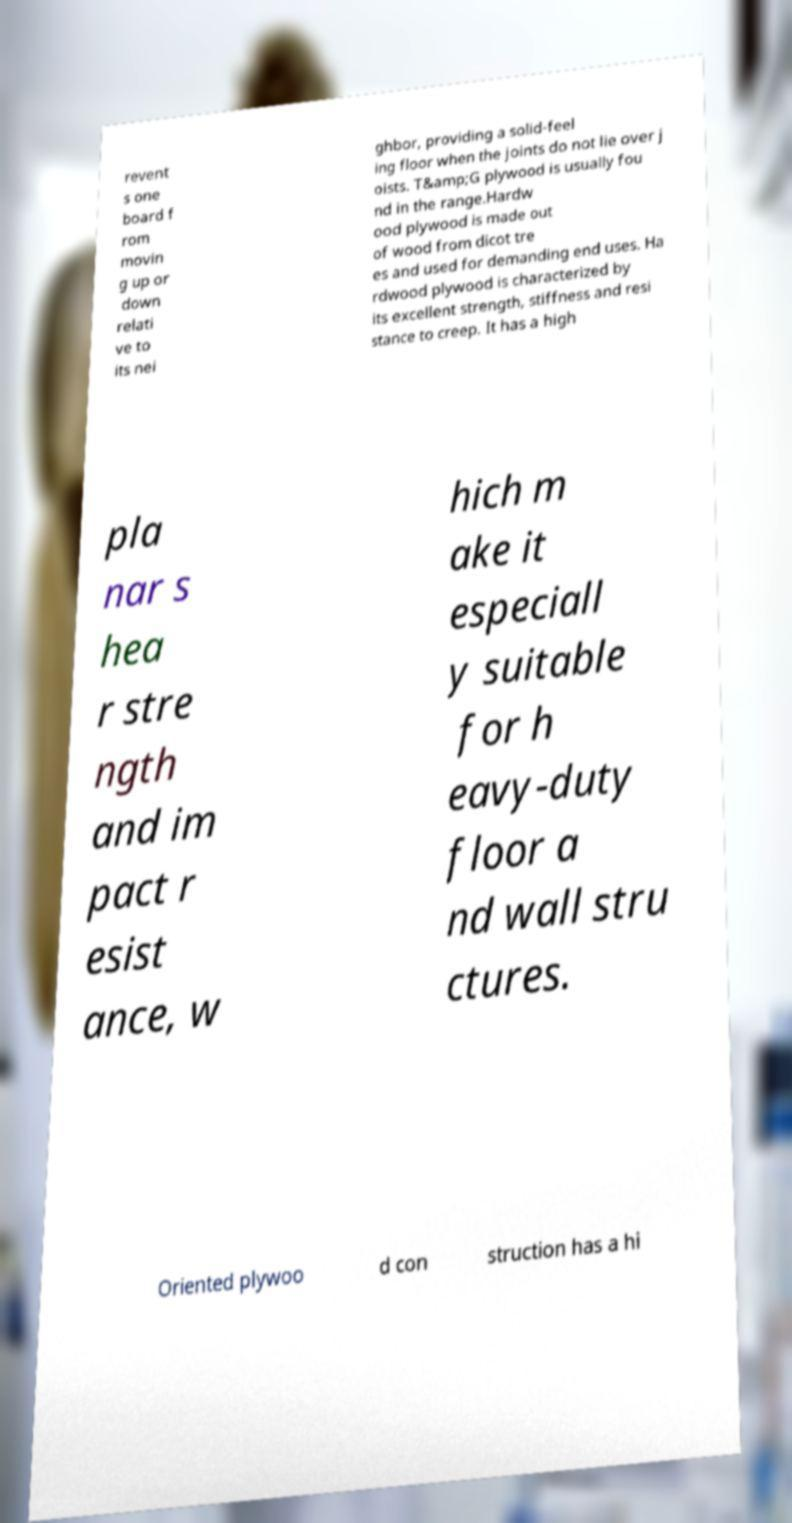What messages or text are displayed in this image? I need them in a readable, typed format. revent s one board f rom movin g up or down relati ve to its nei ghbor, providing a solid-feel ing floor when the joints do not lie over j oists. T&amp;G plywood is usually fou nd in the range.Hardw ood plywood is made out of wood from dicot tre es and used for demanding end uses. Ha rdwood plywood is characterized by its excellent strength, stiffness and resi stance to creep. It has a high pla nar s hea r stre ngth and im pact r esist ance, w hich m ake it especiall y suitable for h eavy-duty floor a nd wall stru ctures. Oriented plywoo d con struction has a hi 